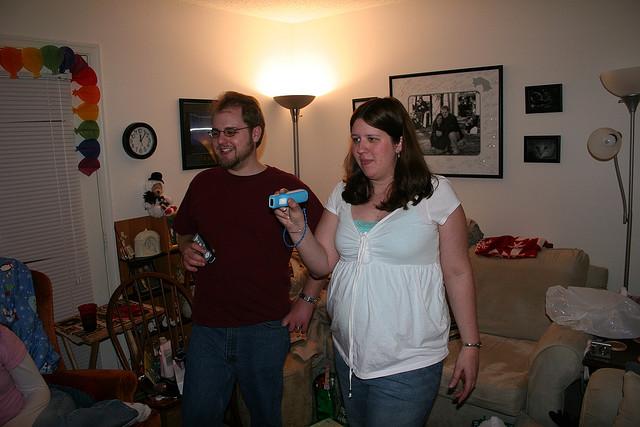Is anybody wearing black pants?
Give a very brief answer. No. What are these women touching?
Write a very short answer. Game controller. What color is the woman's hair?
Answer briefly. Brown. How many people are wearing hats?
Write a very short answer. 0. What game is the man playing?
Quick response, please. Wii. What color is the remote?
Answer briefly. Blue. What color is the man's badge?
Short answer required. No badge. How many people are in the photo?
Give a very brief answer. 2. Are these people all the same age?
Quick response, please. Yes. Is there cake on the chair?
Quick response, please. No. How many people are wearing glasses in this scene?
Quick response, please. 1. Is the lady wearing a dress?
Concise answer only. No. What is the girl playing with?
Be succinct. Wii. Who is wearing glasses?
Give a very brief answer. Man. Are they both wearing black?
Be succinct. No. What color is the person's shirt on the far right?
Answer briefly. White. How many people are in this picture?
Give a very brief answer. 2. What's inside the balloon?
Keep it brief. Air. What character is depicted on the poster above the woman?
Write a very short answer. None. What color is the chair in the background?
Be succinct. Tan. Is there any lights on in the room?
Answer briefly. Yes. Who is in the picture on the wall?
Keep it brief. Couple. How many toolbars do you see?
Write a very short answer. 0. How many people have their hands raised above their shoulders?
Be succinct. 0. What is this room?
Quick response, please. Living room. What is the standing man going to do?
Be succinct. Play wii. How many women are in this photo?
Give a very brief answer. 1. What's the couple doing?
Give a very brief answer. Gaming. How many people are in this photo?
Answer briefly. 2. Is there a celebration going on?
Write a very short answer. Yes. How many kids are there?
Give a very brief answer. 0. Is anyone wearing a tie?
Short answer required. No. What color is the girl's hat?
Short answer required. Brown. Is the man smiling?
Concise answer only. Yes. What is the lightning?
Write a very short answer. Lamp. What color hair does the woman holding the cake have?
Give a very brief answer. Brown. What is the girl doing?
Be succinct. Playing wii. What are they playing with?
Quick response, please. Wii. Is the woman wearing glasses?
Write a very short answer. No. What is on the woman's upper arm?
Be succinct. Shirt. Which man has glasses on?
Give a very brief answer. Left. Is the person on the left in focus?
Quick response, please. Yes. How many cards are attached to the curtain?
Quick response, please. 11. How many people are visible?
Be succinct. 3. How many males do you see?
Give a very brief answer. 1. 